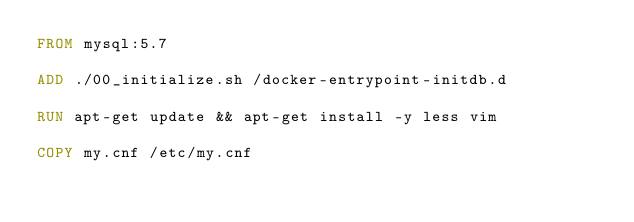Convert code to text. <code><loc_0><loc_0><loc_500><loc_500><_Dockerfile_>FROM mysql:5.7

ADD ./00_initialize.sh /docker-entrypoint-initdb.d

RUN apt-get update && apt-get install -y less vim

COPY my.cnf /etc/my.cnf
</code> 